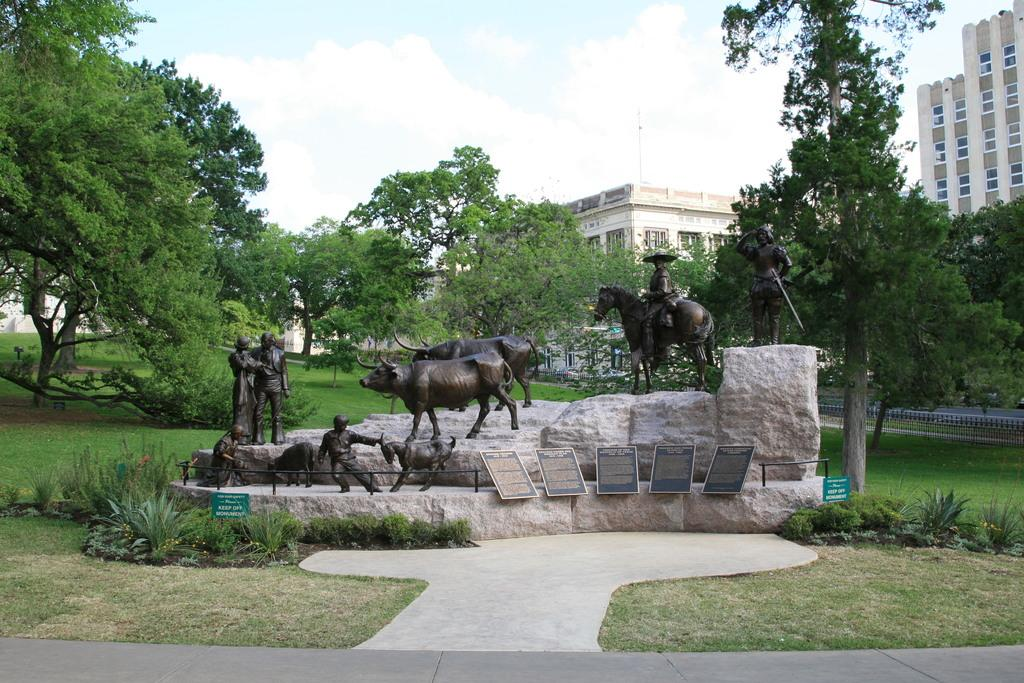What type of natural elements are present in the middle of the image? There are trees in the middle of the image. What type of man-made structures can be seen in the middle of the image? There are buildings in the middle of the image. What type of artistic objects are present in the middle of the image? There are statues in the middle of the image. What is visible at the top of the image? The sky is visible at the top of the image. How many ants are carrying the yoke in the image? There are no ants or yokes present in the image. What is the end of the image used for? The image does not have an end, as it is a two-dimensional representation. 